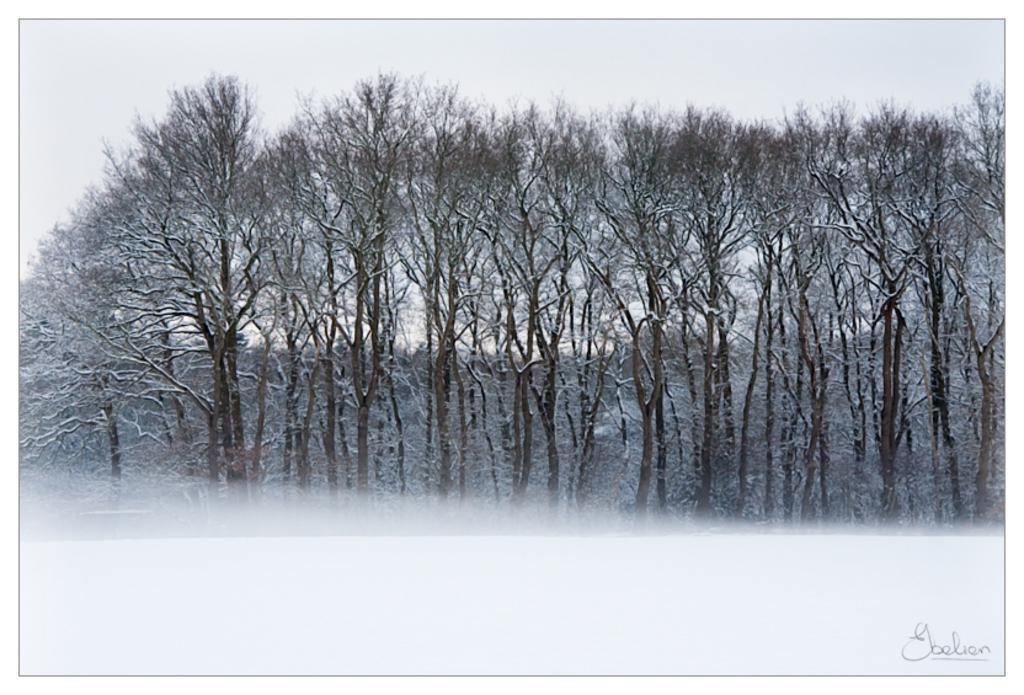Please provide a concise description of this image. In this image we can see some trees and the sky, at the bottom of the image we can see the text. 